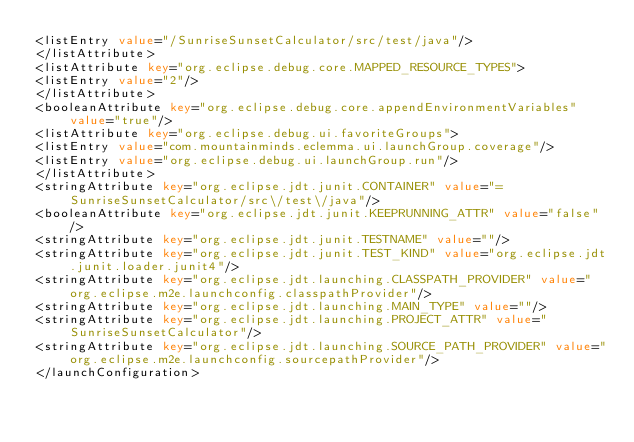Convert code to text. <code><loc_0><loc_0><loc_500><loc_500><_XML_><listEntry value="/SunriseSunsetCalculator/src/test/java"/>
</listAttribute>
<listAttribute key="org.eclipse.debug.core.MAPPED_RESOURCE_TYPES">
<listEntry value="2"/>
</listAttribute>
<booleanAttribute key="org.eclipse.debug.core.appendEnvironmentVariables" value="true"/>
<listAttribute key="org.eclipse.debug.ui.favoriteGroups">
<listEntry value="com.mountainminds.eclemma.ui.launchGroup.coverage"/>
<listEntry value="org.eclipse.debug.ui.launchGroup.run"/>
</listAttribute>
<stringAttribute key="org.eclipse.jdt.junit.CONTAINER" value="=SunriseSunsetCalculator/src\/test\/java"/>
<booleanAttribute key="org.eclipse.jdt.junit.KEEPRUNNING_ATTR" value="false"/>
<stringAttribute key="org.eclipse.jdt.junit.TESTNAME" value=""/>
<stringAttribute key="org.eclipse.jdt.junit.TEST_KIND" value="org.eclipse.jdt.junit.loader.junit4"/>
<stringAttribute key="org.eclipse.jdt.launching.CLASSPATH_PROVIDER" value="org.eclipse.m2e.launchconfig.classpathProvider"/>
<stringAttribute key="org.eclipse.jdt.launching.MAIN_TYPE" value=""/>
<stringAttribute key="org.eclipse.jdt.launching.PROJECT_ATTR" value="SunriseSunsetCalculator"/>
<stringAttribute key="org.eclipse.jdt.launching.SOURCE_PATH_PROVIDER" value="org.eclipse.m2e.launchconfig.sourcepathProvider"/>
</launchConfiguration>
</code> 